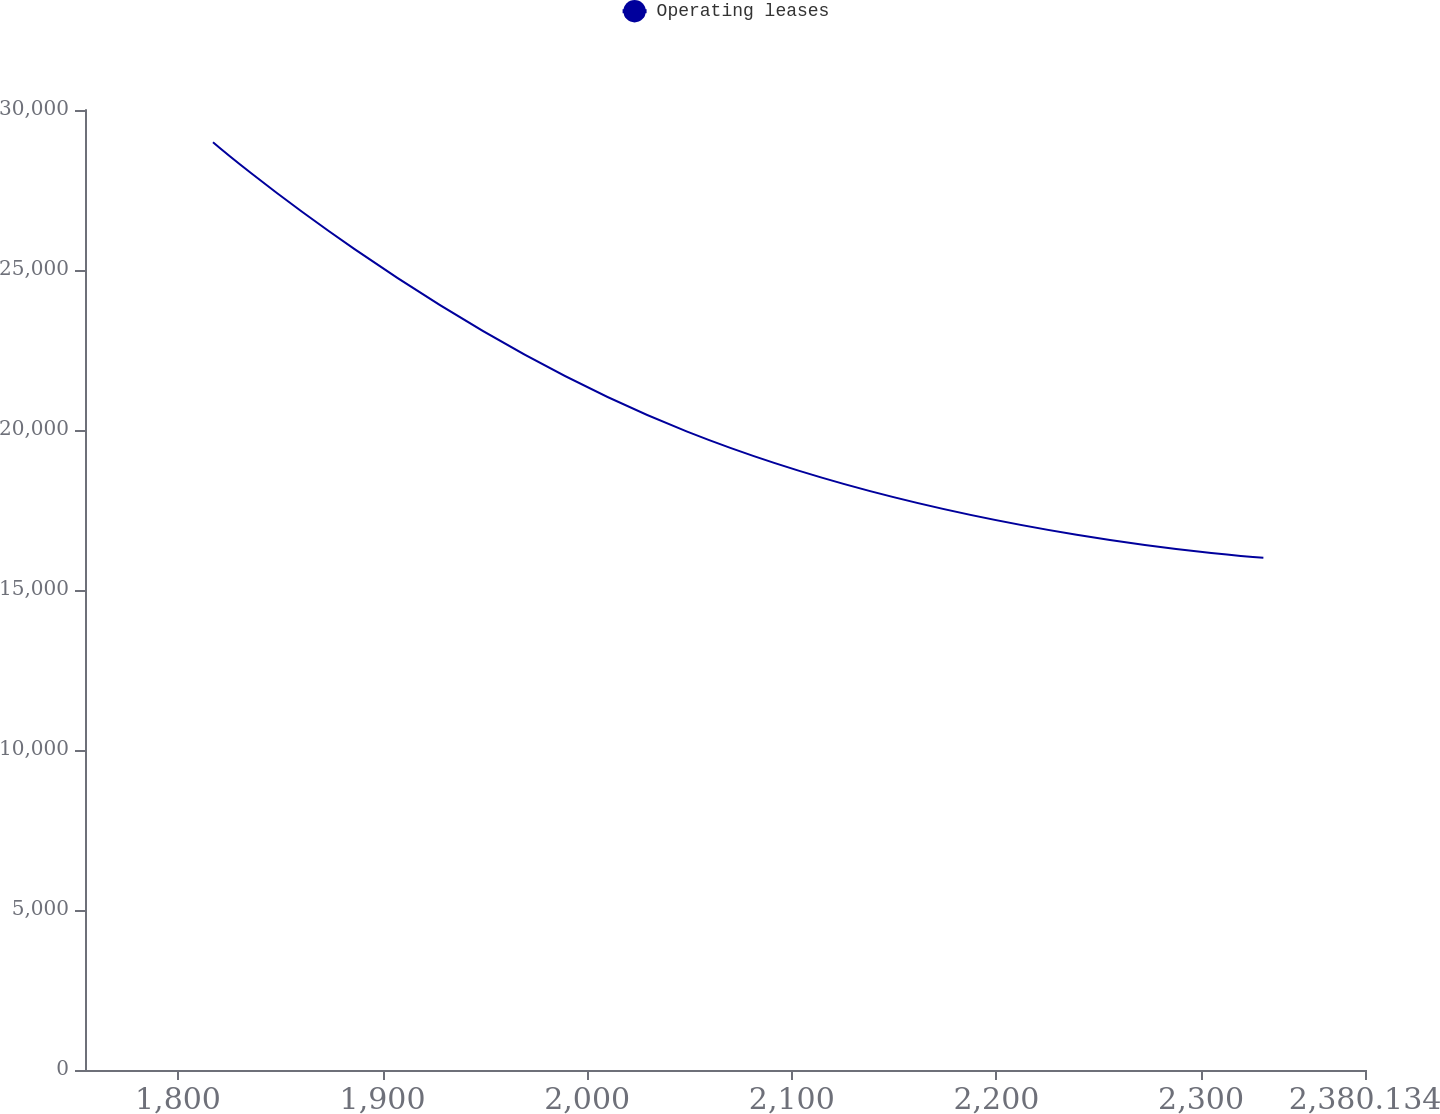<chart> <loc_0><loc_0><loc_500><loc_500><line_chart><ecel><fcel>Operating leases<nl><fcel>1817.13<fcel>28992.1<nl><fcel>2048.87<fcel>19948.8<nl><fcel>2330.47<fcel>16008.9<nl><fcel>2386.58<fcel>12881<nl><fcel>2442.69<fcel>10097.7<nl></chart> 